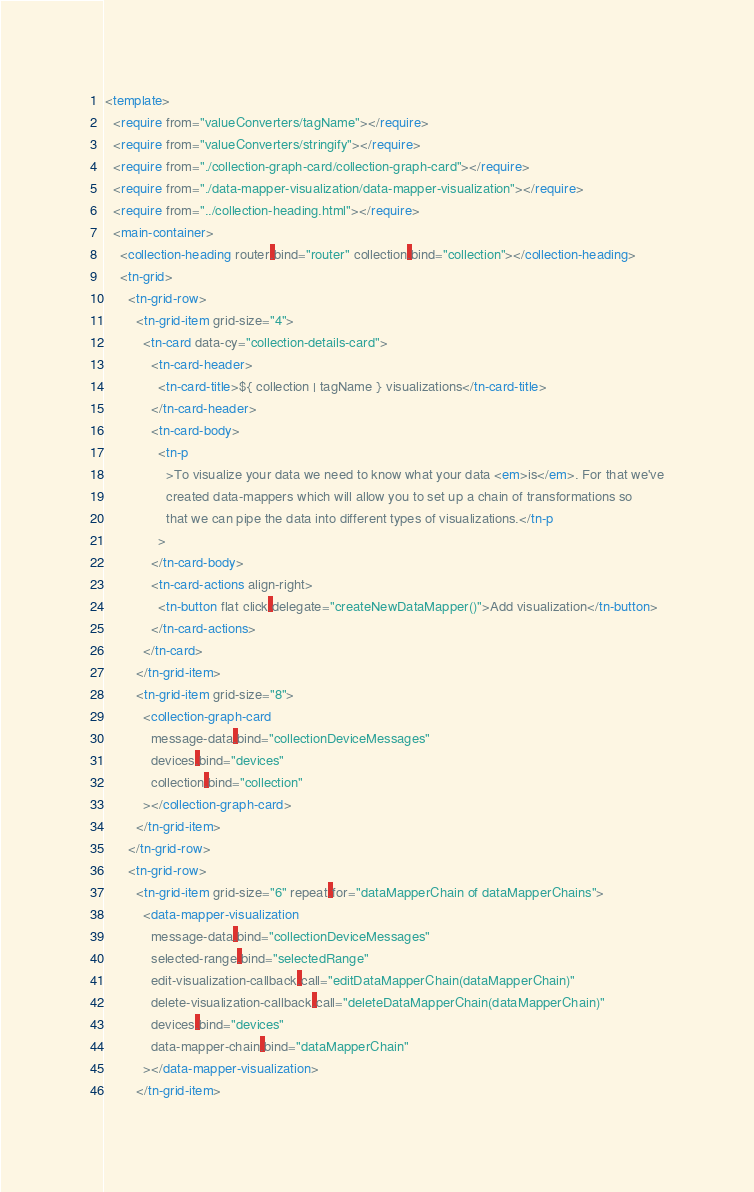<code> <loc_0><loc_0><loc_500><loc_500><_HTML_><template>
  <require from="valueConverters/tagName"></require>
  <require from="valueConverters/stringify"></require>
  <require from="./collection-graph-card/collection-graph-card"></require>
  <require from="./data-mapper-visualization/data-mapper-visualization"></require>
  <require from="../collection-heading.html"></require>
  <main-container>
    <collection-heading router.bind="router" collection.bind="collection"></collection-heading>
    <tn-grid>
      <tn-grid-row>
        <tn-grid-item grid-size="4">
          <tn-card data-cy="collection-details-card">
            <tn-card-header>
              <tn-card-title>${ collection | tagName } visualizations</tn-card-title>
            </tn-card-header>
            <tn-card-body>
              <tn-p
                >To visualize your data we need to know what your data <em>is</em>. For that we've
                created data-mappers which will allow you to set up a chain of transformations so
                that we can pipe the data into different types of visualizations.</tn-p
              >
            </tn-card-body>
            <tn-card-actions align-right>
              <tn-button flat click.delegate="createNewDataMapper()">Add visualization</tn-button>
            </tn-card-actions>
          </tn-card>
        </tn-grid-item>
        <tn-grid-item grid-size="8">
          <collection-graph-card
            message-data.bind="collectionDeviceMessages"
            devices.bind="devices"
            collection.bind="collection"
          ></collection-graph-card>
        </tn-grid-item>
      </tn-grid-row>
      <tn-grid-row>
        <tn-grid-item grid-size="6" repeat.for="dataMapperChain of dataMapperChains">
          <data-mapper-visualization
            message-data.bind="collectionDeviceMessages"
            selected-range.bind="selectedRange"
            edit-visualization-callback.call="editDataMapperChain(dataMapperChain)"
            delete-visualization-callback.call="deleteDataMapperChain(dataMapperChain)"
            devices.bind="devices"
            data-mapper-chain.bind="dataMapperChain"
          ></data-mapper-visualization>
        </tn-grid-item></code> 